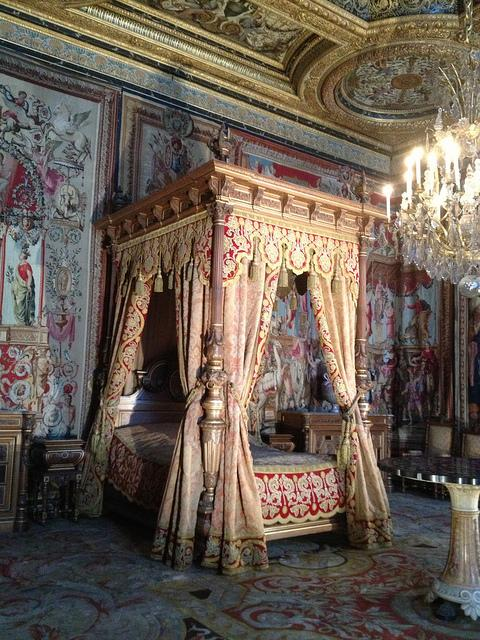What is needed to light the candles on the chandeliers? Please explain your reasoning. fire. Candle wicks work if they are lit by a fire source rather than other sources of energy. 